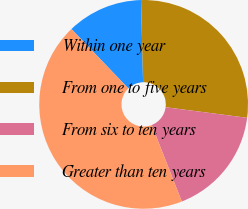Convert chart to OTSL. <chart><loc_0><loc_0><loc_500><loc_500><pie_chart><fcel>Within one year<fcel>From one to five years<fcel>From six to ten years<fcel>Greater than ten years<nl><fcel>11.76%<fcel>27.45%<fcel>16.99%<fcel>43.79%<nl></chart> 